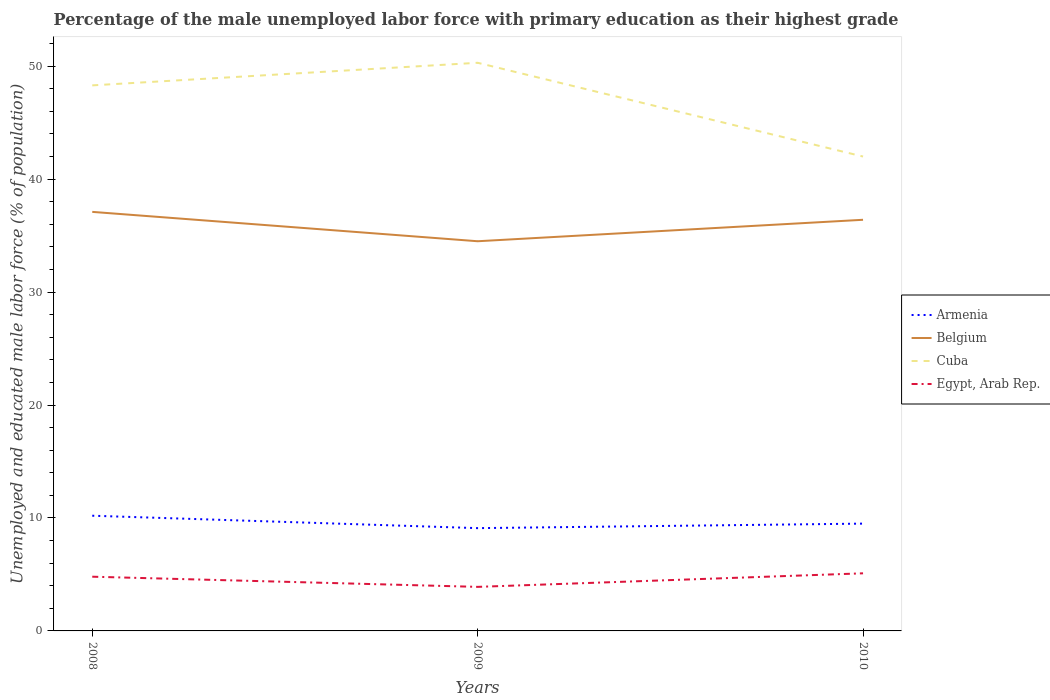Does the line corresponding to Cuba intersect with the line corresponding to Belgium?
Your answer should be compact. No. Across all years, what is the maximum percentage of the unemployed male labor force with primary education in Belgium?
Offer a terse response. 34.5. What is the total percentage of the unemployed male labor force with primary education in Belgium in the graph?
Offer a very short reply. 2.6. What is the difference between the highest and the second highest percentage of the unemployed male labor force with primary education in Armenia?
Ensure brevity in your answer.  1.1. How many lines are there?
Keep it short and to the point. 4. How many years are there in the graph?
Your response must be concise. 3. What is the difference between two consecutive major ticks on the Y-axis?
Keep it short and to the point. 10. Where does the legend appear in the graph?
Provide a short and direct response. Center right. How many legend labels are there?
Your answer should be compact. 4. What is the title of the graph?
Ensure brevity in your answer.  Percentage of the male unemployed labor force with primary education as their highest grade. Does "Chile" appear as one of the legend labels in the graph?
Provide a short and direct response. No. What is the label or title of the X-axis?
Make the answer very short. Years. What is the label or title of the Y-axis?
Offer a very short reply. Unemployed and educated male labor force (% of population). What is the Unemployed and educated male labor force (% of population) in Armenia in 2008?
Provide a short and direct response. 10.2. What is the Unemployed and educated male labor force (% of population) of Belgium in 2008?
Give a very brief answer. 37.1. What is the Unemployed and educated male labor force (% of population) in Cuba in 2008?
Offer a terse response. 48.3. What is the Unemployed and educated male labor force (% of population) in Egypt, Arab Rep. in 2008?
Provide a short and direct response. 4.8. What is the Unemployed and educated male labor force (% of population) of Armenia in 2009?
Provide a succinct answer. 9.1. What is the Unemployed and educated male labor force (% of population) of Belgium in 2009?
Give a very brief answer. 34.5. What is the Unemployed and educated male labor force (% of population) of Cuba in 2009?
Make the answer very short. 50.3. What is the Unemployed and educated male labor force (% of population) of Egypt, Arab Rep. in 2009?
Ensure brevity in your answer.  3.9. What is the Unemployed and educated male labor force (% of population) of Armenia in 2010?
Offer a terse response. 9.5. What is the Unemployed and educated male labor force (% of population) of Belgium in 2010?
Your response must be concise. 36.4. What is the Unemployed and educated male labor force (% of population) of Egypt, Arab Rep. in 2010?
Your response must be concise. 5.1. Across all years, what is the maximum Unemployed and educated male labor force (% of population) of Armenia?
Your answer should be very brief. 10.2. Across all years, what is the maximum Unemployed and educated male labor force (% of population) in Belgium?
Ensure brevity in your answer.  37.1. Across all years, what is the maximum Unemployed and educated male labor force (% of population) of Cuba?
Provide a short and direct response. 50.3. Across all years, what is the maximum Unemployed and educated male labor force (% of population) of Egypt, Arab Rep.?
Your response must be concise. 5.1. Across all years, what is the minimum Unemployed and educated male labor force (% of population) in Armenia?
Give a very brief answer. 9.1. Across all years, what is the minimum Unemployed and educated male labor force (% of population) in Belgium?
Your answer should be very brief. 34.5. Across all years, what is the minimum Unemployed and educated male labor force (% of population) in Cuba?
Keep it short and to the point. 42. Across all years, what is the minimum Unemployed and educated male labor force (% of population) in Egypt, Arab Rep.?
Offer a terse response. 3.9. What is the total Unemployed and educated male labor force (% of population) in Armenia in the graph?
Your answer should be very brief. 28.8. What is the total Unemployed and educated male labor force (% of population) in Belgium in the graph?
Provide a succinct answer. 108. What is the total Unemployed and educated male labor force (% of population) of Cuba in the graph?
Your response must be concise. 140.6. What is the total Unemployed and educated male labor force (% of population) in Egypt, Arab Rep. in the graph?
Your answer should be very brief. 13.8. What is the difference between the Unemployed and educated male labor force (% of population) in Armenia in 2008 and that in 2009?
Give a very brief answer. 1.1. What is the difference between the Unemployed and educated male labor force (% of population) of Cuba in 2008 and that in 2009?
Provide a succinct answer. -2. What is the difference between the Unemployed and educated male labor force (% of population) in Armenia in 2008 and that in 2010?
Make the answer very short. 0.7. What is the difference between the Unemployed and educated male labor force (% of population) in Cuba in 2008 and that in 2010?
Your response must be concise. 6.3. What is the difference between the Unemployed and educated male labor force (% of population) in Belgium in 2009 and that in 2010?
Keep it short and to the point. -1.9. What is the difference between the Unemployed and educated male labor force (% of population) of Cuba in 2009 and that in 2010?
Keep it short and to the point. 8.3. What is the difference between the Unemployed and educated male labor force (% of population) of Egypt, Arab Rep. in 2009 and that in 2010?
Ensure brevity in your answer.  -1.2. What is the difference between the Unemployed and educated male labor force (% of population) of Armenia in 2008 and the Unemployed and educated male labor force (% of population) of Belgium in 2009?
Make the answer very short. -24.3. What is the difference between the Unemployed and educated male labor force (% of population) in Armenia in 2008 and the Unemployed and educated male labor force (% of population) in Cuba in 2009?
Provide a short and direct response. -40.1. What is the difference between the Unemployed and educated male labor force (% of population) of Belgium in 2008 and the Unemployed and educated male labor force (% of population) of Cuba in 2009?
Offer a terse response. -13.2. What is the difference between the Unemployed and educated male labor force (% of population) in Belgium in 2008 and the Unemployed and educated male labor force (% of population) in Egypt, Arab Rep. in 2009?
Provide a short and direct response. 33.2. What is the difference between the Unemployed and educated male labor force (% of population) of Cuba in 2008 and the Unemployed and educated male labor force (% of population) of Egypt, Arab Rep. in 2009?
Make the answer very short. 44.4. What is the difference between the Unemployed and educated male labor force (% of population) of Armenia in 2008 and the Unemployed and educated male labor force (% of population) of Belgium in 2010?
Your response must be concise. -26.2. What is the difference between the Unemployed and educated male labor force (% of population) of Armenia in 2008 and the Unemployed and educated male labor force (% of population) of Cuba in 2010?
Offer a terse response. -31.8. What is the difference between the Unemployed and educated male labor force (% of population) in Armenia in 2008 and the Unemployed and educated male labor force (% of population) in Egypt, Arab Rep. in 2010?
Offer a terse response. 5.1. What is the difference between the Unemployed and educated male labor force (% of population) of Belgium in 2008 and the Unemployed and educated male labor force (% of population) of Cuba in 2010?
Provide a succinct answer. -4.9. What is the difference between the Unemployed and educated male labor force (% of population) of Cuba in 2008 and the Unemployed and educated male labor force (% of population) of Egypt, Arab Rep. in 2010?
Your answer should be very brief. 43.2. What is the difference between the Unemployed and educated male labor force (% of population) of Armenia in 2009 and the Unemployed and educated male labor force (% of population) of Belgium in 2010?
Your answer should be very brief. -27.3. What is the difference between the Unemployed and educated male labor force (% of population) in Armenia in 2009 and the Unemployed and educated male labor force (% of population) in Cuba in 2010?
Provide a short and direct response. -32.9. What is the difference between the Unemployed and educated male labor force (% of population) in Armenia in 2009 and the Unemployed and educated male labor force (% of population) in Egypt, Arab Rep. in 2010?
Provide a short and direct response. 4. What is the difference between the Unemployed and educated male labor force (% of population) in Belgium in 2009 and the Unemployed and educated male labor force (% of population) in Egypt, Arab Rep. in 2010?
Keep it short and to the point. 29.4. What is the difference between the Unemployed and educated male labor force (% of population) of Cuba in 2009 and the Unemployed and educated male labor force (% of population) of Egypt, Arab Rep. in 2010?
Offer a very short reply. 45.2. What is the average Unemployed and educated male labor force (% of population) in Armenia per year?
Keep it short and to the point. 9.6. What is the average Unemployed and educated male labor force (% of population) of Belgium per year?
Offer a very short reply. 36. What is the average Unemployed and educated male labor force (% of population) in Cuba per year?
Your answer should be compact. 46.87. In the year 2008, what is the difference between the Unemployed and educated male labor force (% of population) in Armenia and Unemployed and educated male labor force (% of population) in Belgium?
Offer a very short reply. -26.9. In the year 2008, what is the difference between the Unemployed and educated male labor force (% of population) of Armenia and Unemployed and educated male labor force (% of population) of Cuba?
Make the answer very short. -38.1. In the year 2008, what is the difference between the Unemployed and educated male labor force (% of population) of Belgium and Unemployed and educated male labor force (% of population) of Egypt, Arab Rep.?
Your answer should be compact. 32.3. In the year 2008, what is the difference between the Unemployed and educated male labor force (% of population) of Cuba and Unemployed and educated male labor force (% of population) of Egypt, Arab Rep.?
Your response must be concise. 43.5. In the year 2009, what is the difference between the Unemployed and educated male labor force (% of population) of Armenia and Unemployed and educated male labor force (% of population) of Belgium?
Provide a short and direct response. -25.4. In the year 2009, what is the difference between the Unemployed and educated male labor force (% of population) of Armenia and Unemployed and educated male labor force (% of population) of Cuba?
Provide a short and direct response. -41.2. In the year 2009, what is the difference between the Unemployed and educated male labor force (% of population) in Belgium and Unemployed and educated male labor force (% of population) in Cuba?
Offer a terse response. -15.8. In the year 2009, what is the difference between the Unemployed and educated male labor force (% of population) in Belgium and Unemployed and educated male labor force (% of population) in Egypt, Arab Rep.?
Make the answer very short. 30.6. In the year 2009, what is the difference between the Unemployed and educated male labor force (% of population) in Cuba and Unemployed and educated male labor force (% of population) in Egypt, Arab Rep.?
Your response must be concise. 46.4. In the year 2010, what is the difference between the Unemployed and educated male labor force (% of population) in Armenia and Unemployed and educated male labor force (% of population) in Belgium?
Give a very brief answer. -26.9. In the year 2010, what is the difference between the Unemployed and educated male labor force (% of population) of Armenia and Unemployed and educated male labor force (% of population) of Cuba?
Make the answer very short. -32.5. In the year 2010, what is the difference between the Unemployed and educated male labor force (% of population) in Belgium and Unemployed and educated male labor force (% of population) in Egypt, Arab Rep.?
Keep it short and to the point. 31.3. In the year 2010, what is the difference between the Unemployed and educated male labor force (% of population) of Cuba and Unemployed and educated male labor force (% of population) of Egypt, Arab Rep.?
Offer a very short reply. 36.9. What is the ratio of the Unemployed and educated male labor force (% of population) in Armenia in 2008 to that in 2009?
Make the answer very short. 1.12. What is the ratio of the Unemployed and educated male labor force (% of population) in Belgium in 2008 to that in 2009?
Provide a succinct answer. 1.08. What is the ratio of the Unemployed and educated male labor force (% of population) in Cuba in 2008 to that in 2009?
Give a very brief answer. 0.96. What is the ratio of the Unemployed and educated male labor force (% of population) in Egypt, Arab Rep. in 2008 to that in 2009?
Your answer should be very brief. 1.23. What is the ratio of the Unemployed and educated male labor force (% of population) in Armenia in 2008 to that in 2010?
Your response must be concise. 1.07. What is the ratio of the Unemployed and educated male labor force (% of population) of Belgium in 2008 to that in 2010?
Your answer should be compact. 1.02. What is the ratio of the Unemployed and educated male labor force (% of population) in Cuba in 2008 to that in 2010?
Your answer should be very brief. 1.15. What is the ratio of the Unemployed and educated male labor force (% of population) of Egypt, Arab Rep. in 2008 to that in 2010?
Give a very brief answer. 0.94. What is the ratio of the Unemployed and educated male labor force (% of population) of Armenia in 2009 to that in 2010?
Make the answer very short. 0.96. What is the ratio of the Unemployed and educated male labor force (% of population) of Belgium in 2009 to that in 2010?
Make the answer very short. 0.95. What is the ratio of the Unemployed and educated male labor force (% of population) of Cuba in 2009 to that in 2010?
Make the answer very short. 1.2. What is the ratio of the Unemployed and educated male labor force (% of population) in Egypt, Arab Rep. in 2009 to that in 2010?
Your response must be concise. 0.76. What is the difference between the highest and the second highest Unemployed and educated male labor force (% of population) in Belgium?
Your answer should be compact. 0.7. What is the difference between the highest and the second highest Unemployed and educated male labor force (% of population) of Egypt, Arab Rep.?
Provide a succinct answer. 0.3. What is the difference between the highest and the lowest Unemployed and educated male labor force (% of population) of Armenia?
Keep it short and to the point. 1.1. What is the difference between the highest and the lowest Unemployed and educated male labor force (% of population) in Belgium?
Provide a succinct answer. 2.6. What is the difference between the highest and the lowest Unemployed and educated male labor force (% of population) in Cuba?
Offer a very short reply. 8.3. What is the difference between the highest and the lowest Unemployed and educated male labor force (% of population) in Egypt, Arab Rep.?
Keep it short and to the point. 1.2. 